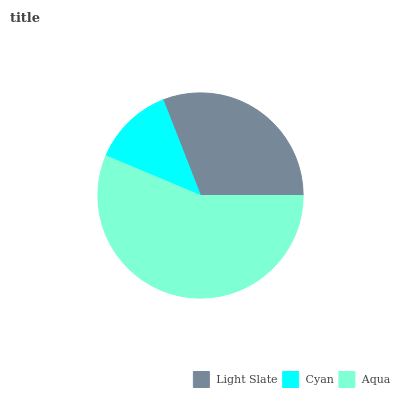Is Cyan the minimum?
Answer yes or no. Yes. Is Aqua the maximum?
Answer yes or no. Yes. Is Aqua the minimum?
Answer yes or no. No. Is Cyan the maximum?
Answer yes or no. No. Is Aqua greater than Cyan?
Answer yes or no. Yes. Is Cyan less than Aqua?
Answer yes or no. Yes. Is Cyan greater than Aqua?
Answer yes or no. No. Is Aqua less than Cyan?
Answer yes or no. No. Is Light Slate the high median?
Answer yes or no. Yes. Is Light Slate the low median?
Answer yes or no. Yes. Is Aqua the high median?
Answer yes or no. No. Is Aqua the low median?
Answer yes or no. No. 